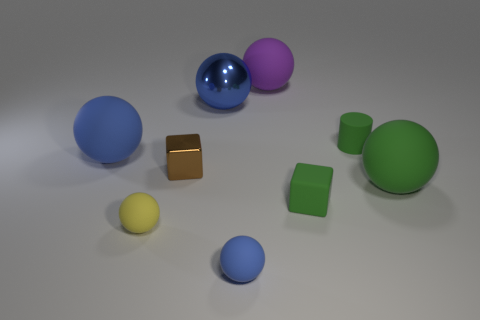Subtract all large purple matte balls. How many balls are left? 5 Subtract all green blocks. How many blue balls are left? 3 Add 1 purple things. How many objects exist? 10 Subtract all brown blocks. How many blocks are left? 1 Subtract all cylinders. How many objects are left? 8 Subtract 2 cubes. How many cubes are left? 0 Subtract all cyan cylinders. Subtract all blue spheres. How many cylinders are left? 1 Add 9 big green cylinders. How many big green cylinders exist? 9 Subtract 0 cyan cubes. How many objects are left? 9 Subtract all green matte spheres. Subtract all purple objects. How many objects are left? 7 